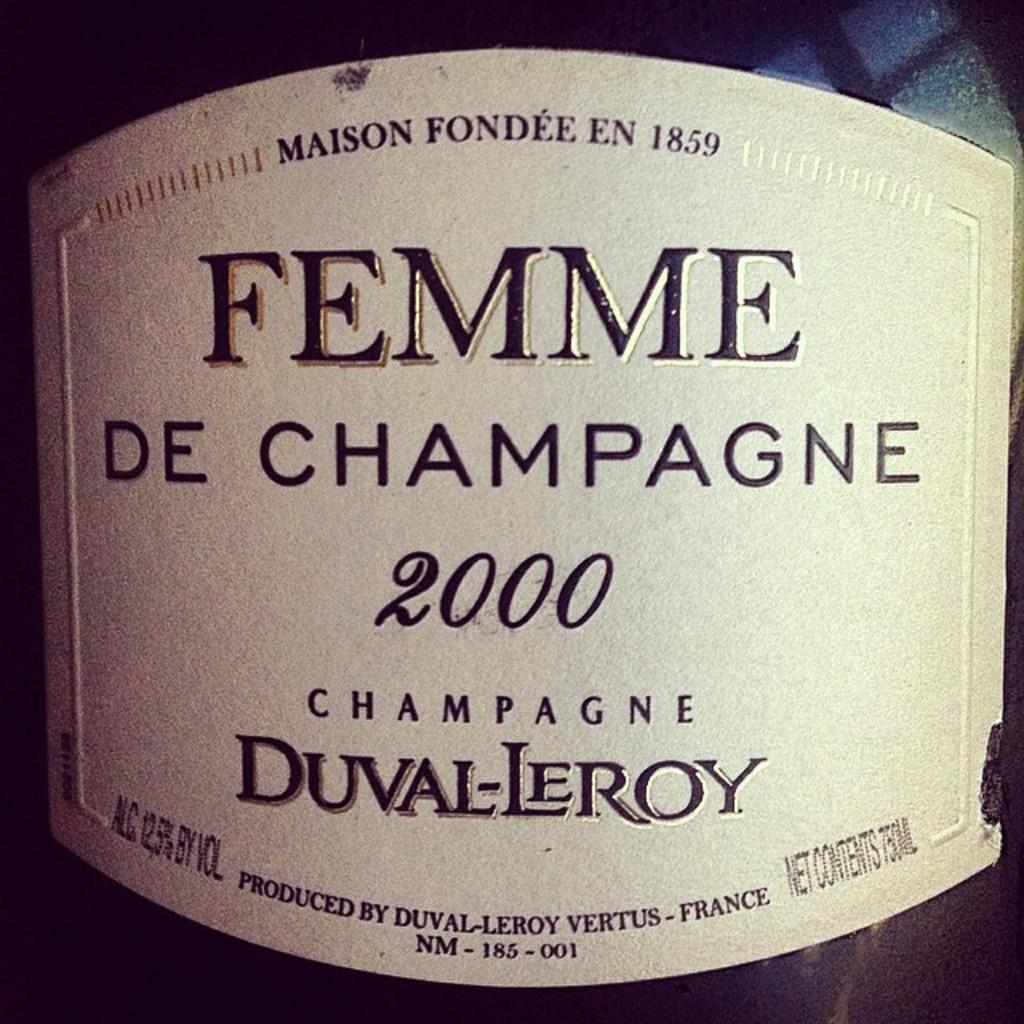What is the brand?
Keep it short and to the point. Femme de champagne. 